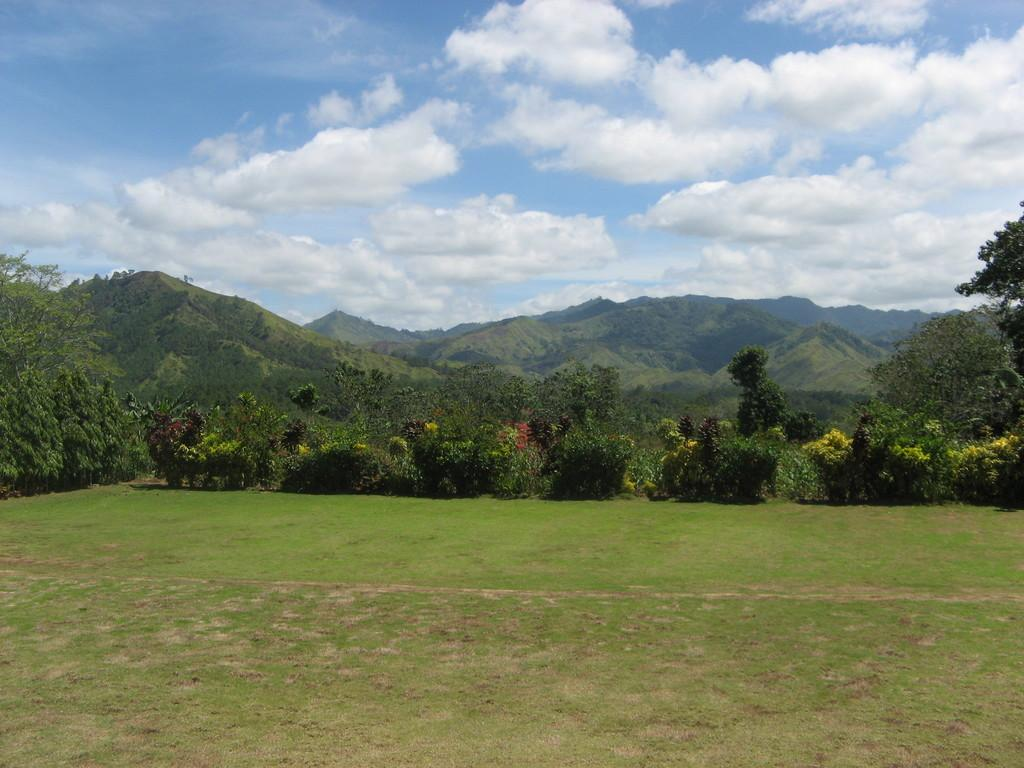What type of vegetation can be seen in the image? There is grass, trees, and plants in the image. What type of natural landform is visible in the image? There are mountains in the image. What part of the natural environment is visible in the image? The sky is visible in the image. What type of organization is responsible for maintaining the riddle in the image? There is no riddle present in the image, and therefore no organization is responsible for maintaining it. 